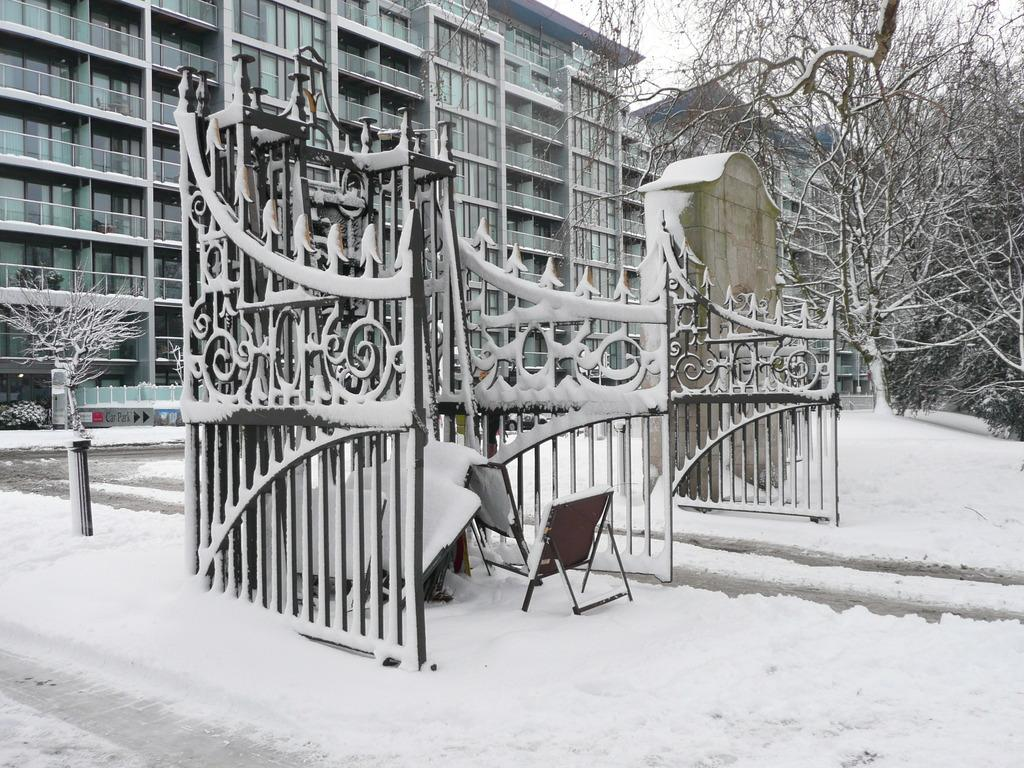What type of structure is visible in the image? There is a building in the image. What is in front of the building? The building has a gate in front of it. How is the gate affected by the weather? The gate is covered with snow. What type of vegetation is near the building? There are trees near the building. How are the trees affected by the weather? The trees are also covered with snow. Can you see a boat navigating through the rainstorm in the image? There is no boat or rainstorm present in the image; it features a building with a snow-covered gate and snow-covered trees. 